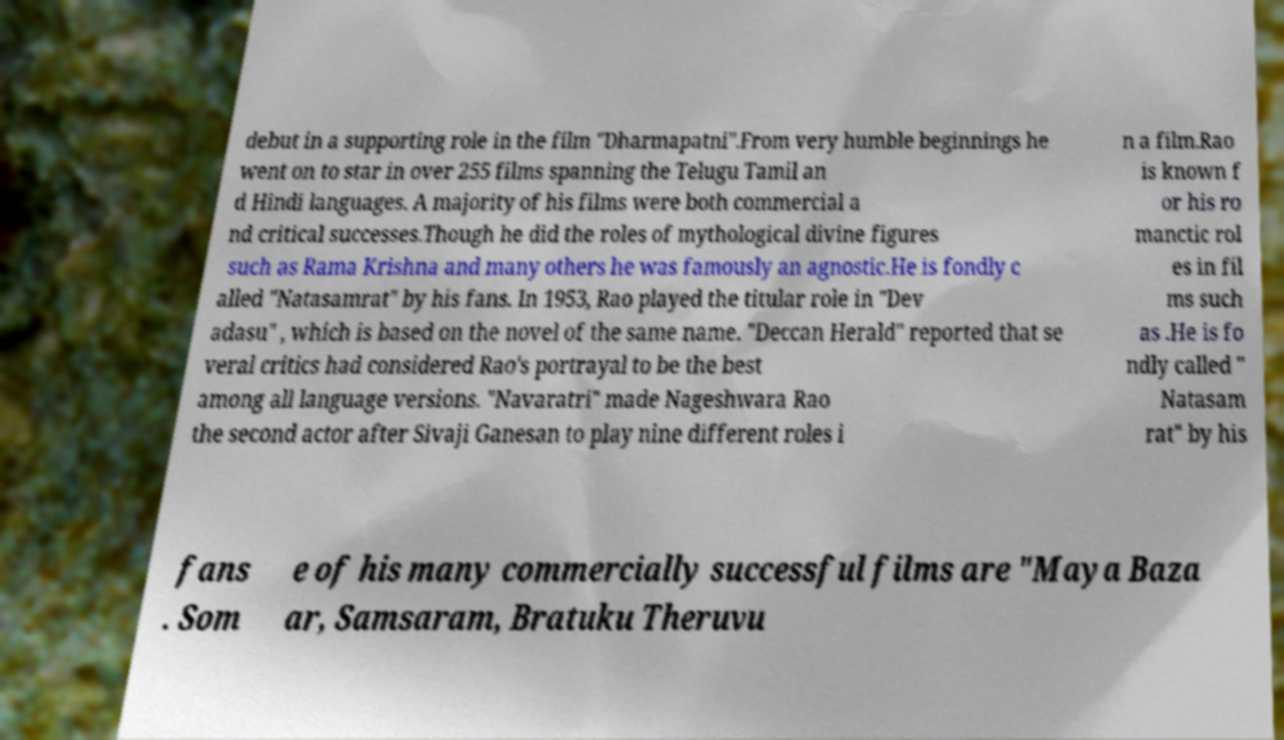I need the written content from this picture converted into text. Can you do that? debut in a supporting role in the film "Dharmapatni".From very humble beginnings he went on to star in over 255 films spanning the Telugu Tamil an d Hindi languages. A majority of his films were both commercial a nd critical successes.Though he did the roles of mythological divine figures such as Rama Krishna and many others he was famously an agnostic.He is fondly c alled "Natasamrat" by his fans. In 1953, Rao played the titular role in "Dev adasu" , which is based on the novel of the same name. "Deccan Herald" reported that se veral critics had considered Rao's portrayal to be the best among all language versions. "Navaratri" made Nageshwara Rao the second actor after Sivaji Ganesan to play nine different roles i n a film.Rao is known f or his ro manctic rol es in fil ms such as .He is fo ndly called " Natasam rat" by his fans . Som e of his many commercially successful films are "Maya Baza ar, Samsaram, Bratuku Theruvu 